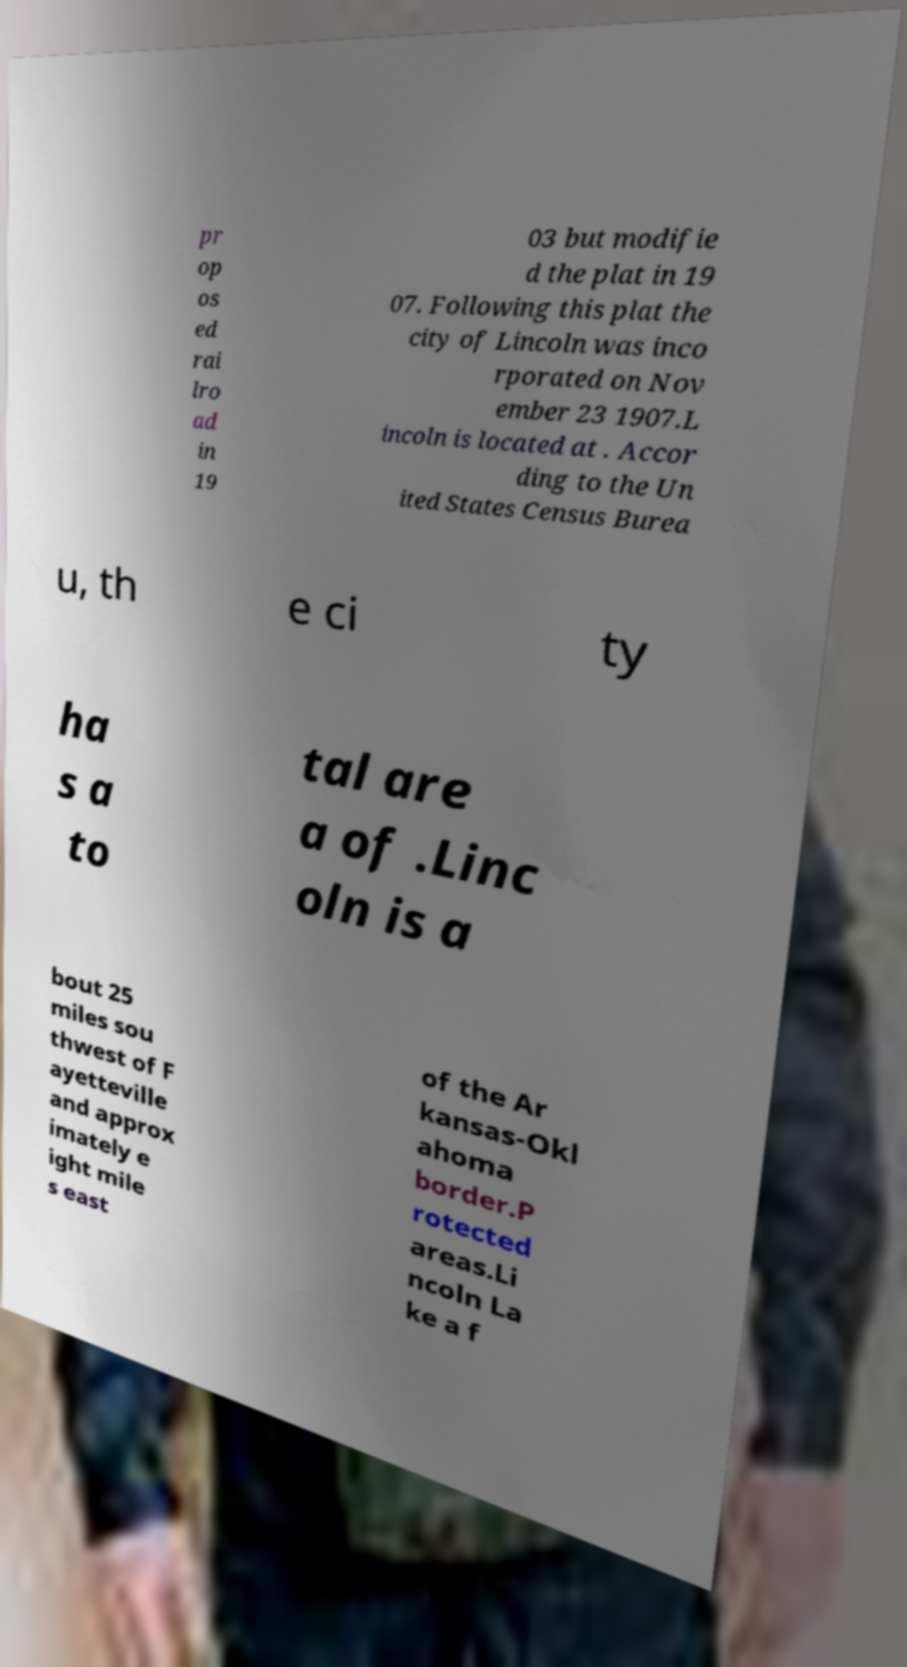Please read and relay the text visible in this image. What does it say? pr op os ed rai lro ad in 19 03 but modifie d the plat in 19 07. Following this plat the city of Lincoln was inco rporated on Nov ember 23 1907.L incoln is located at . Accor ding to the Un ited States Census Burea u, th e ci ty ha s a to tal are a of .Linc oln is a bout 25 miles sou thwest of F ayetteville and approx imately e ight mile s east of the Ar kansas-Okl ahoma border.P rotected areas.Li ncoln La ke a f 